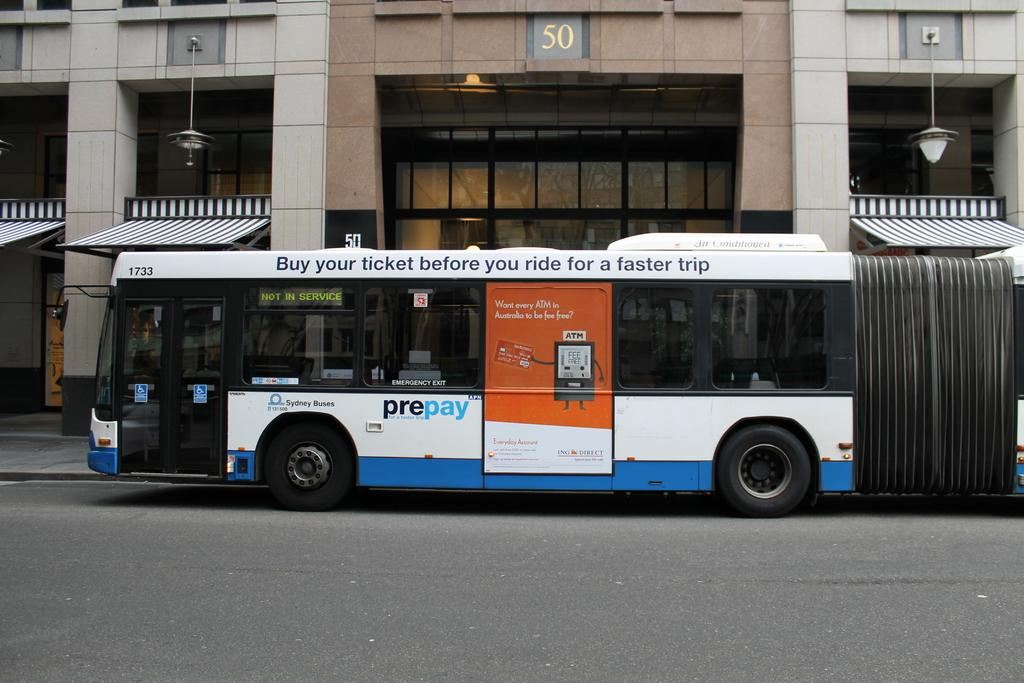<image>
Summarize the visual content of the image. A long bus advertises to buy your ticket before you ride for a faster trip along its top. 